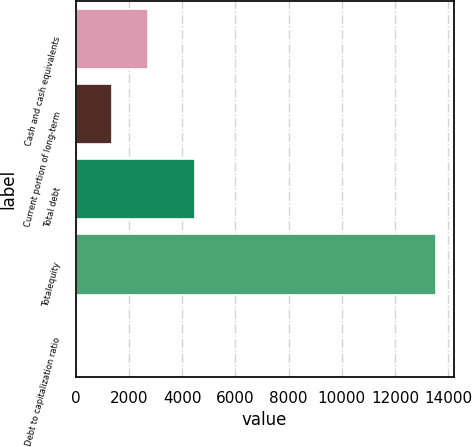Convert chart. <chart><loc_0><loc_0><loc_500><loc_500><bar_chart><fcel>Cash and cash equivalents<fcel>Current portion of long-term<fcel>Total debt<fcel>Totalequity<fcel>Debt to capitalization ratio<nl><fcel>2725.44<fcel>1375.12<fcel>4467<fcel>13528<fcel>24.8<nl></chart> 